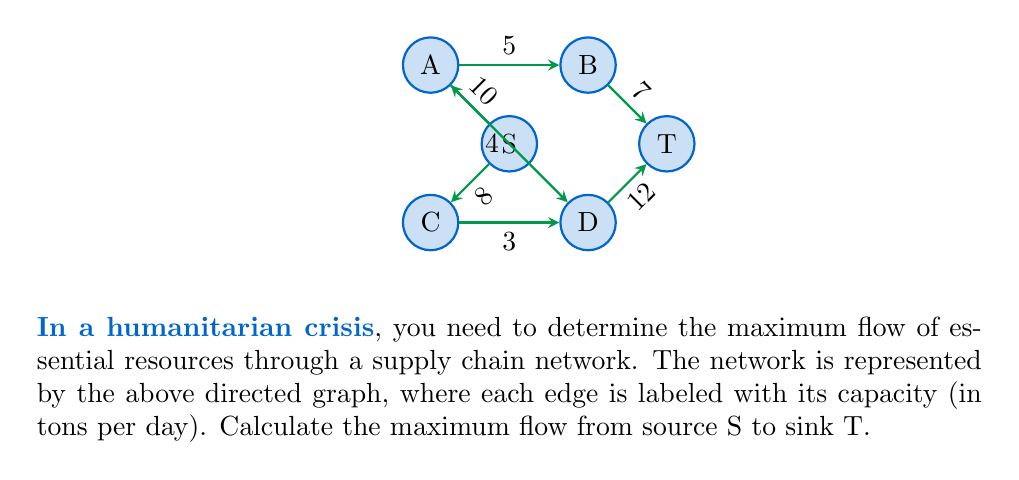Could you help me with this problem? To solve this maximum flow problem, we'll use the Ford-Fulkerson algorithm:

1) Initialize flow to 0 for all edges.

2) Find an augmenting path from S to T:
   Path 1: S → A → B → T (min capacity: 5)
   Update flow: 
   S → A: 5/10
   A → B: 5/5
   B → T: 5/7
   Max flow so far: 5

3) Find another augmenting path:
   Path 2: S → A → D → T (min capacity: 4)
   Update flow:
   S → A: 9/10
   A → D: 4/4
   D → T: 4/12
   Max flow so far: 9

4) Find another augmenting path:
   Path 3: S → C → D → T (min capacity: 3)
   Update flow:
   S → C: 3/8
   C → D: 3/3
   D → T: 7/12
   Max flow so far: 12

5) Find another augmenting path:
   Path 4: S → C → D → T (min capacity: 1)
   Update flow:
   S → C: 4/8
   D → T: 8/12
   Max flow so far: 13

6) No more augmenting paths exist. The algorithm terminates.

The maximum flow is the sum of all flows leaving the source S, which is 13 tons per day.
Answer: 13 tons per day 